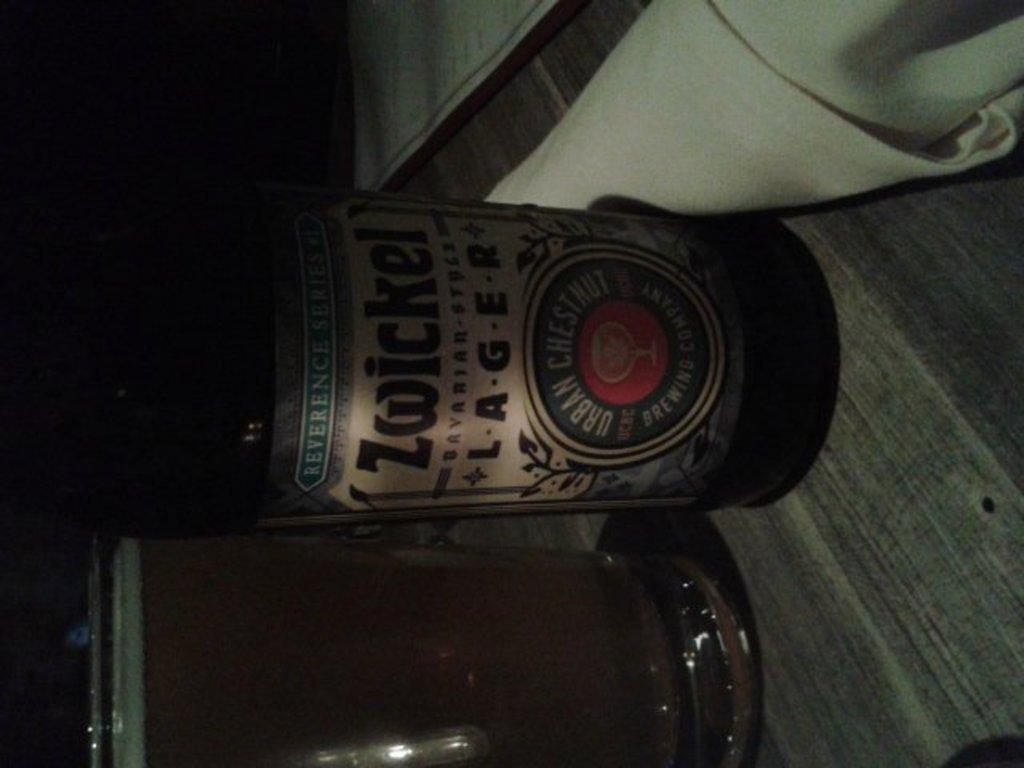<image>
Provide a brief description of the given image. A bottle of "Zwicker Lager" beer on a table. 